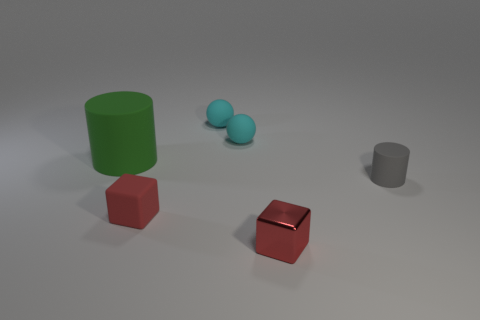There is a shiny thing that is the same color as the small matte block; what is its shape?
Provide a succinct answer. Cube. Are there an equal number of gray objects that are in front of the metallic thing and large purple matte spheres?
Your answer should be very brief. Yes. There is a cylinder that is behind the gray rubber object; what size is it?
Provide a succinct answer. Large. How many small objects are red things or balls?
Offer a terse response. 4. There is a tiny thing that is the same shape as the large object; what color is it?
Ensure brevity in your answer.  Gray. Is the size of the metallic thing the same as the gray thing?
Give a very brief answer. Yes. What number of objects are gray cylinders or matte things that are to the left of the small gray cylinder?
Your answer should be very brief. 5. The small thing that is in front of the tiny rubber thing that is in front of the tiny gray rubber cylinder is what color?
Make the answer very short. Red. Does the matte object that is in front of the gray rubber cylinder have the same color as the tiny metal cube?
Your answer should be compact. Yes. What material is the cylinder that is to the right of the green thing?
Keep it short and to the point. Rubber. 